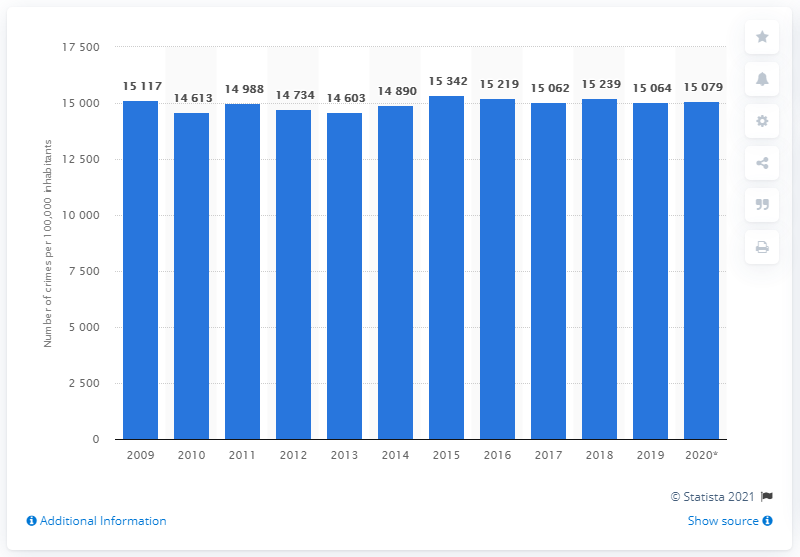Can you describe the trend in crime rate in Sweden from 2009 to 2020? The bar graph shows a fluctuating trend in the crime rate in Sweden from 2009 to 2020. Initially, there was a slight decrease from 2009 to 2014, with some minor ups and downs. The crime rate peaked in 2015, followed by a gradual decrease until 2018. From 2018 to 2019, there's a slight increase, and a subsequent decrease in 2020, ending the period with a lower crime rate than the peak of 2015. 